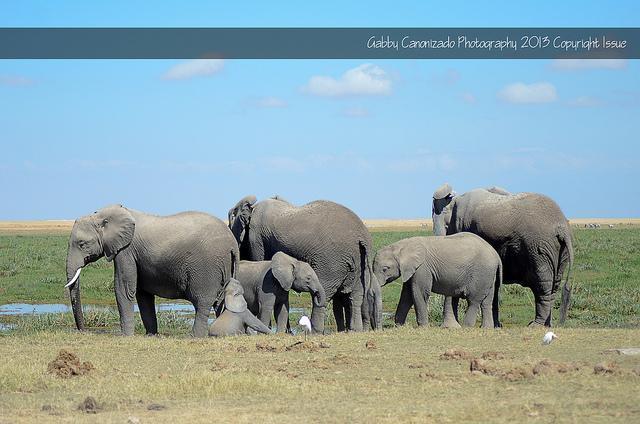How many tusks are visible?
Give a very brief answer. 1. How many elephants are there?
Give a very brief answer. 5. How many people behind the fence are wearing red hats ?
Give a very brief answer. 0. 